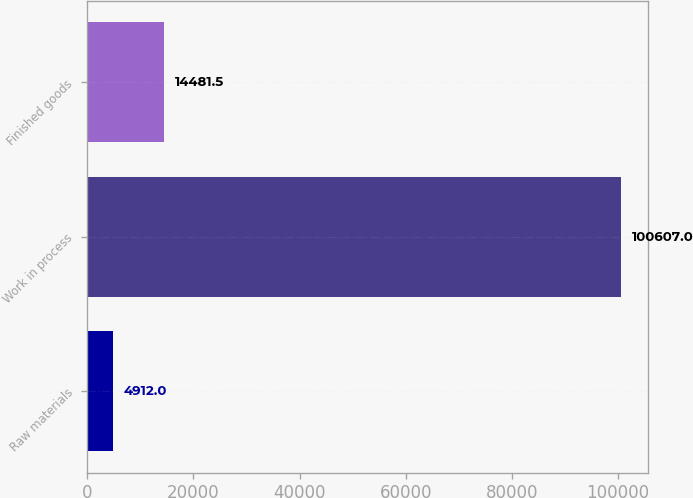<chart> <loc_0><loc_0><loc_500><loc_500><bar_chart><fcel>Raw materials<fcel>Work in process<fcel>Finished goods<nl><fcel>4912<fcel>100607<fcel>14481.5<nl></chart> 